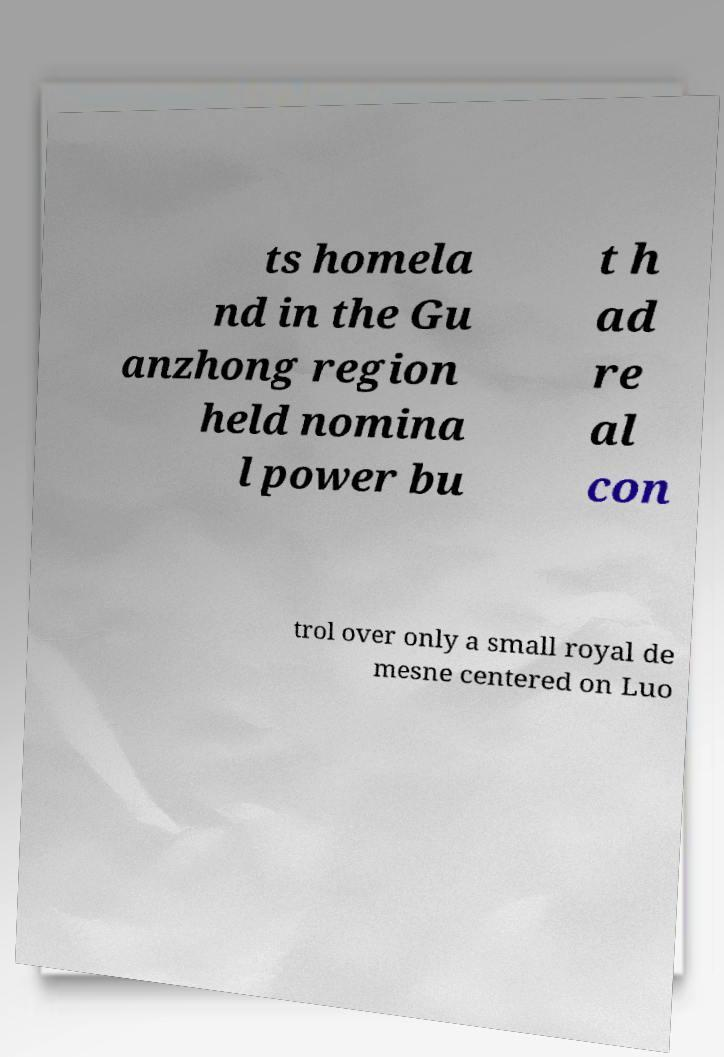There's text embedded in this image that I need extracted. Can you transcribe it verbatim? ts homela nd in the Gu anzhong region held nomina l power bu t h ad re al con trol over only a small royal de mesne centered on Luo 